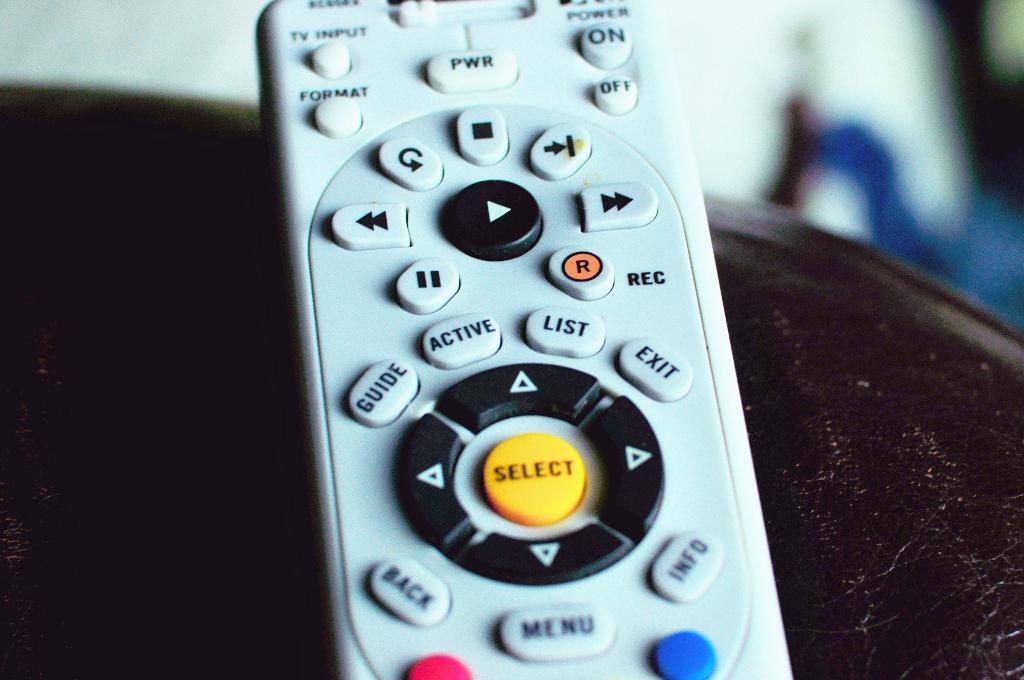What does the yellow button in the middle of the arrow buttons do?
Make the answer very short. Select. What does the top left button say?
Offer a terse response. Tv input. 